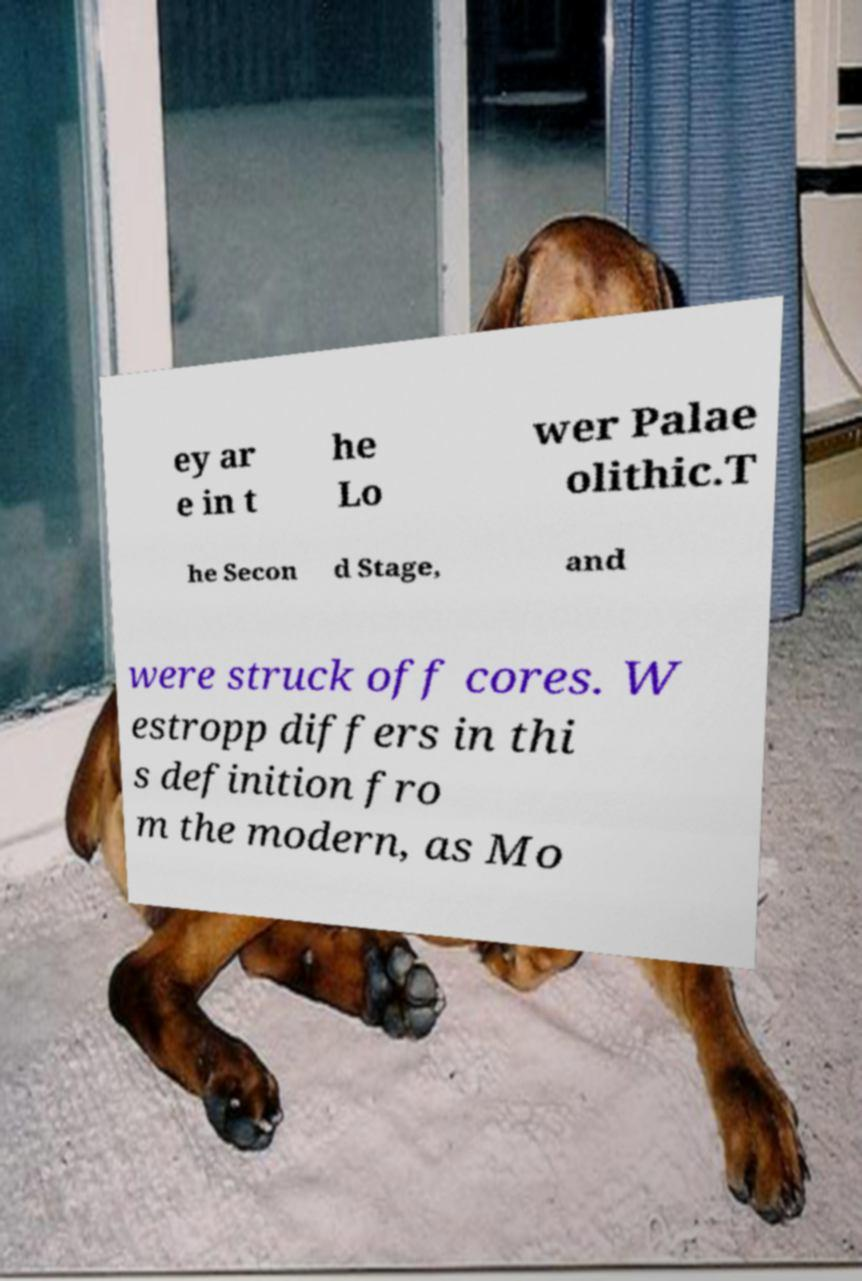Could you assist in decoding the text presented in this image and type it out clearly? ey ar e in t he Lo wer Palae olithic.T he Secon d Stage, and were struck off cores. W estropp differs in thi s definition fro m the modern, as Mo 